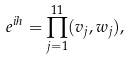<formula> <loc_0><loc_0><loc_500><loc_500>e ^ { i h } = \prod _ { j = 1 } ^ { 1 1 } ( v _ { j } , w _ { j } ) ,</formula> 